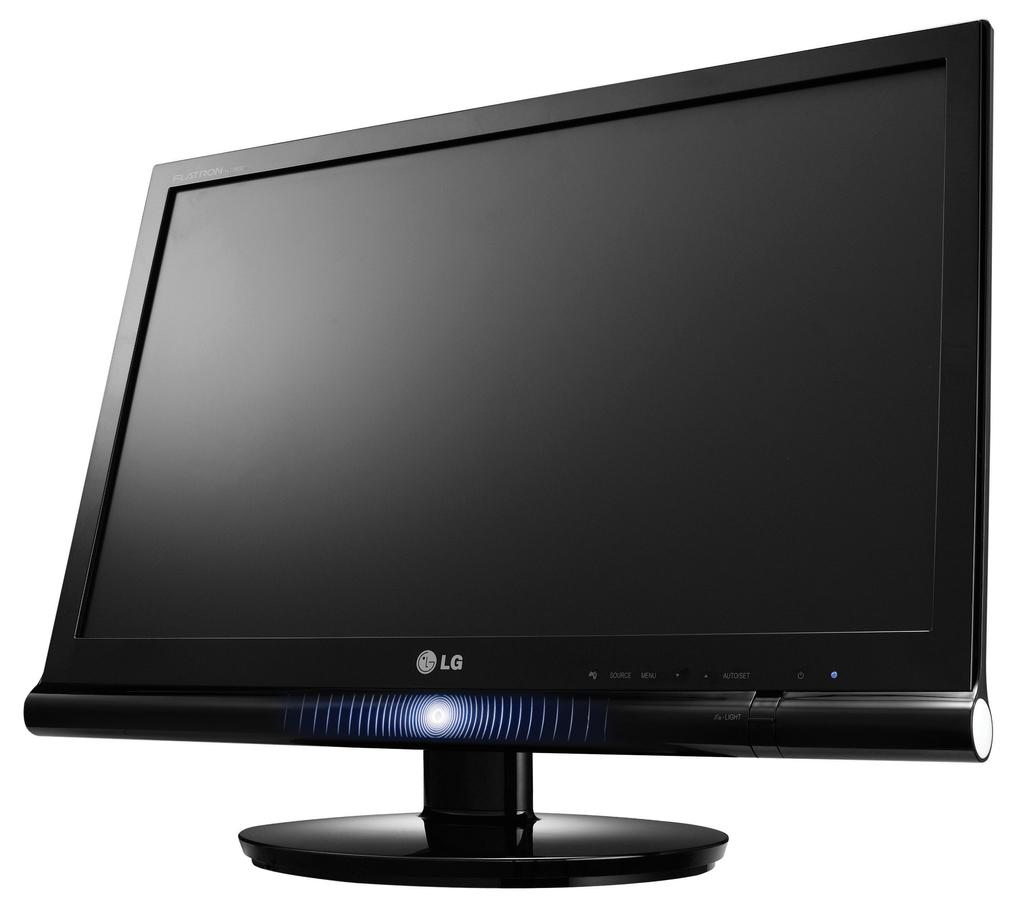<image>
Give a short and clear explanation of the subsequent image. The black computer monitor screen is made by LG. 